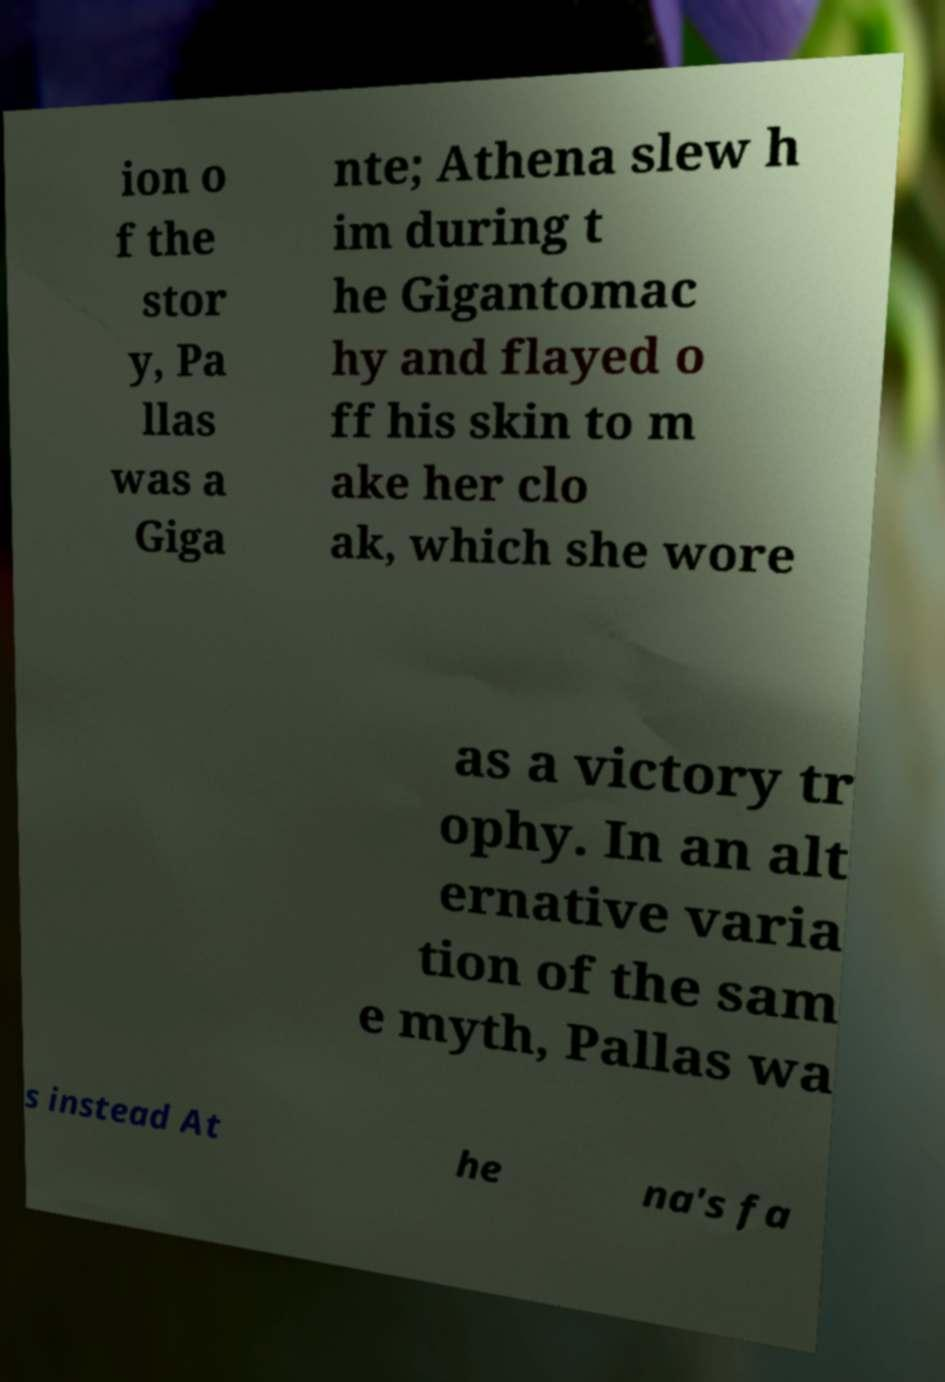Could you assist in decoding the text presented in this image and type it out clearly? ion o f the stor y, Pa llas was a Giga nte; Athena slew h im during t he Gigantomac hy and flayed o ff his skin to m ake her clo ak, which she wore as a victory tr ophy. In an alt ernative varia tion of the sam e myth, Pallas wa s instead At he na's fa 